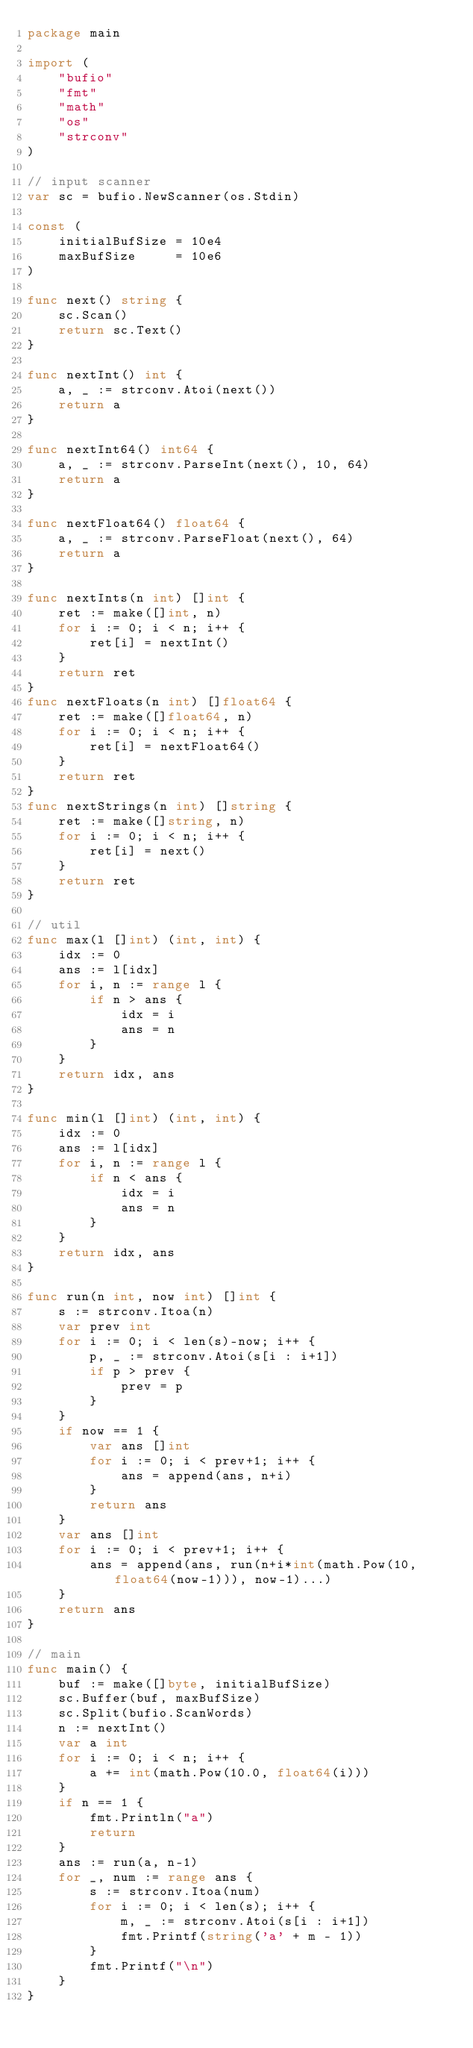Convert code to text. <code><loc_0><loc_0><loc_500><loc_500><_Go_>package main

import (
	"bufio"
	"fmt"
	"math"
	"os"
	"strconv"
)

// input scanner
var sc = bufio.NewScanner(os.Stdin)

const (
	initialBufSize = 10e4
	maxBufSize     = 10e6
)

func next() string {
	sc.Scan()
	return sc.Text()
}

func nextInt() int {
	a, _ := strconv.Atoi(next())
	return a
}

func nextInt64() int64 {
	a, _ := strconv.ParseInt(next(), 10, 64)
	return a
}

func nextFloat64() float64 {
	a, _ := strconv.ParseFloat(next(), 64)
	return a
}

func nextInts(n int) []int {
	ret := make([]int, n)
	for i := 0; i < n; i++ {
		ret[i] = nextInt()
	}
	return ret
}
func nextFloats(n int) []float64 {
	ret := make([]float64, n)
	for i := 0; i < n; i++ {
		ret[i] = nextFloat64()
	}
	return ret
}
func nextStrings(n int) []string {
	ret := make([]string, n)
	for i := 0; i < n; i++ {
		ret[i] = next()
	}
	return ret
}

// util
func max(l []int) (int, int) {
	idx := 0
	ans := l[idx]
	for i, n := range l {
		if n > ans {
			idx = i
			ans = n
		}
	}
	return idx, ans
}

func min(l []int) (int, int) {
	idx := 0
	ans := l[idx]
	for i, n := range l {
		if n < ans {
			idx = i
			ans = n
		}
	}
	return idx, ans
}

func run(n int, now int) []int {
	s := strconv.Itoa(n)
	var prev int
	for i := 0; i < len(s)-now; i++ {
		p, _ := strconv.Atoi(s[i : i+1])
		if p > prev {
			prev = p
		}
	}
	if now == 1 {
		var ans []int
		for i := 0; i < prev+1; i++ {
			ans = append(ans, n+i)
		}
		return ans
	}
	var ans []int
	for i := 0; i < prev+1; i++ {
		ans = append(ans, run(n+i*int(math.Pow(10, float64(now-1))), now-1)...)
	}
	return ans
}

// main
func main() {
	buf := make([]byte, initialBufSize)
	sc.Buffer(buf, maxBufSize)
	sc.Split(bufio.ScanWords)
	n := nextInt()
	var a int
	for i := 0; i < n; i++ {
		a += int(math.Pow(10.0, float64(i)))
	}
	if n == 1 {
		fmt.Println("a")
		return
	}
	ans := run(a, n-1)
	for _, num := range ans {
		s := strconv.Itoa(num)
		for i := 0; i < len(s); i++ {
			m, _ := strconv.Atoi(s[i : i+1])
			fmt.Printf(string('a' + m - 1))
		}
		fmt.Printf("\n")
	}
}
</code> 